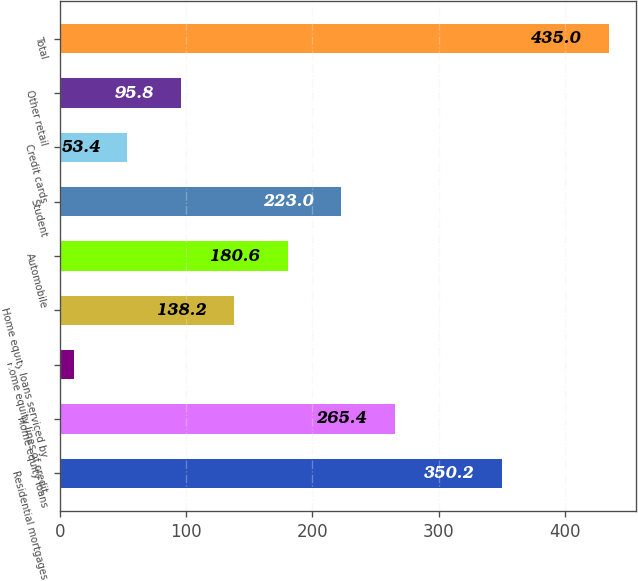Convert chart. <chart><loc_0><loc_0><loc_500><loc_500><bar_chart><fcel>Residential mortgages<fcel>Home equity loans<fcel>Home equity lines of credit<fcel>Home equity loans serviced by<fcel>Automobile<fcel>Student<fcel>Credit cards<fcel>Other retail<fcel>Total<nl><fcel>350.2<fcel>265.4<fcel>11<fcel>138.2<fcel>180.6<fcel>223<fcel>53.4<fcel>95.8<fcel>435<nl></chart> 